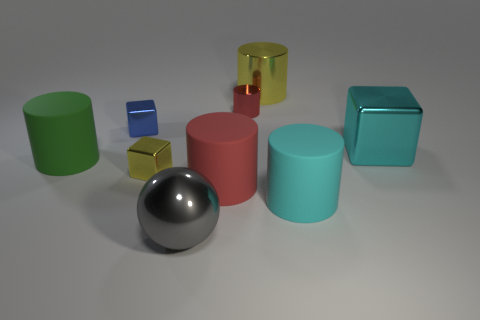Are there fewer tiny metallic cylinders than shiny objects?
Your answer should be very brief. Yes. There is a thing that is to the left of the yellow metallic cube and right of the large green matte thing; what shape is it?
Give a very brief answer. Cube. What number of large blue things are there?
Offer a terse response. 0. There is a large cyan object that is on the left side of the metallic object right of the large cyan object that is in front of the large green cylinder; what is its material?
Keep it short and to the point. Rubber. There is a cyan object that is on the right side of the big cyan matte thing; what number of big gray metal things are to the right of it?
Your answer should be very brief. 0. The small object that is the same shape as the big red object is what color?
Offer a very short reply. Red. Is the material of the small yellow block the same as the small red thing?
Give a very brief answer. Yes. How many cylinders are big rubber objects or tiny red objects?
Make the answer very short. 4. There is a block in front of the large green thing in front of the metallic object right of the big metal cylinder; what is its size?
Provide a short and direct response. Small. What size is the other red metallic object that is the same shape as the large red object?
Provide a short and direct response. Small. 